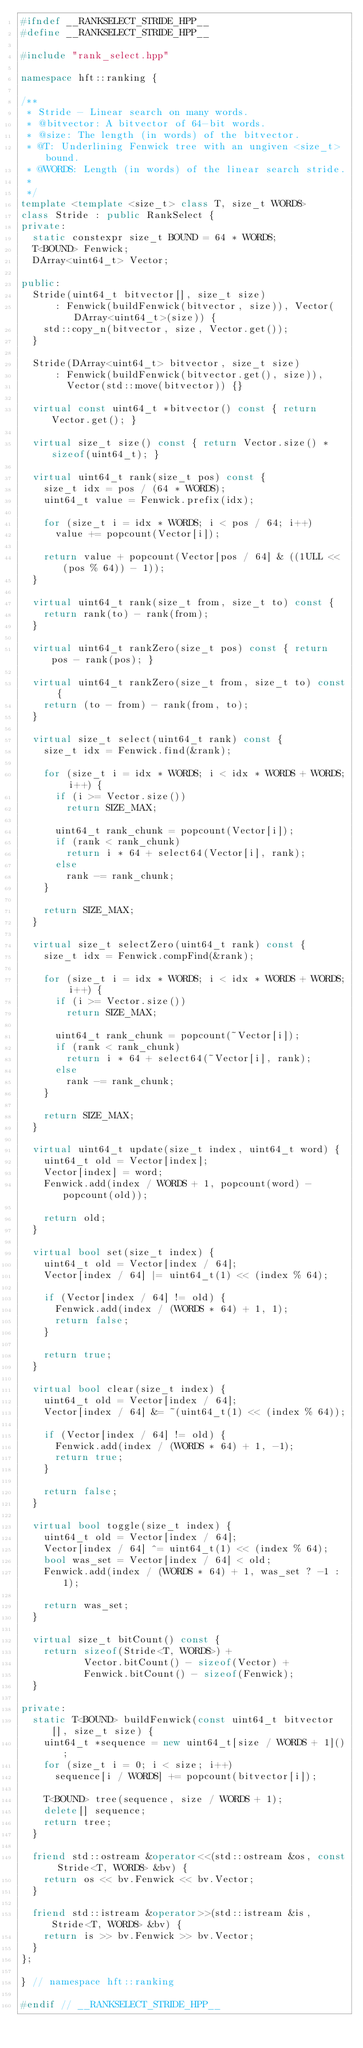Convert code to text. <code><loc_0><loc_0><loc_500><loc_500><_C++_>#ifndef __RANKSELECT_STRIDE_HPP__
#define __RANKSELECT_STRIDE_HPP__

#include "rank_select.hpp"

namespace hft::ranking {

/**
 * Stride - Linear search on many words.
 * @bitvector: A bitvector of 64-bit words.
 * @size: The length (in words) of the bitvector.
 * @T: Underlining Fenwick tree with an ungiven <size_t> bound.
 * @WORDS: Length (in words) of the linear search stride.
 *
 */
template <template <size_t> class T, size_t WORDS>
class Stride : public RankSelect {
private:
  static constexpr size_t BOUND = 64 * WORDS;
  T<BOUND> Fenwick;
  DArray<uint64_t> Vector;

public:
  Stride(uint64_t bitvector[], size_t size)
      : Fenwick(buildFenwick(bitvector, size)), Vector(DArray<uint64_t>(size)) {
    std::copy_n(bitvector, size, Vector.get());
  }

  Stride(DArray<uint64_t> bitvector, size_t size)
      : Fenwick(buildFenwick(bitvector.get(), size)),
        Vector(std::move(bitvector)) {}

  virtual const uint64_t *bitvector() const { return Vector.get(); }

  virtual size_t size() const { return Vector.size() * sizeof(uint64_t); }

  virtual uint64_t rank(size_t pos) const {
    size_t idx = pos / (64 * WORDS);
    uint64_t value = Fenwick.prefix(idx);

    for (size_t i = idx * WORDS; i < pos / 64; i++)
      value += popcount(Vector[i]);

    return value + popcount(Vector[pos / 64] & ((1ULL << (pos % 64)) - 1));
  }

  virtual uint64_t rank(size_t from, size_t to) const {
    return rank(to) - rank(from);
  }

  virtual uint64_t rankZero(size_t pos) const { return pos - rank(pos); }

  virtual uint64_t rankZero(size_t from, size_t to) const {
    return (to - from) - rank(from, to);
  }

  virtual size_t select(uint64_t rank) const {
    size_t idx = Fenwick.find(&rank);

    for (size_t i = idx * WORDS; i < idx * WORDS + WORDS; i++) {
      if (i >= Vector.size())
        return SIZE_MAX;

      uint64_t rank_chunk = popcount(Vector[i]);
      if (rank < rank_chunk)
        return i * 64 + select64(Vector[i], rank);
      else
        rank -= rank_chunk;
    }

    return SIZE_MAX;
  }

  virtual size_t selectZero(uint64_t rank) const {
    size_t idx = Fenwick.compFind(&rank);

    for (size_t i = idx * WORDS; i < idx * WORDS + WORDS; i++) {
      if (i >= Vector.size())
        return SIZE_MAX;

      uint64_t rank_chunk = popcount(~Vector[i]);
      if (rank < rank_chunk)
        return i * 64 + select64(~Vector[i], rank);
      else
        rank -= rank_chunk;
    }

    return SIZE_MAX;
  }

  virtual uint64_t update(size_t index, uint64_t word) {
    uint64_t old = Vector[index];
    Vector[index] = word;
    Fenwick.add(index / WORDS + 1, popcount(word) - popcount(old));

    return old;
  }

  virtual bool set(size_t index) {
    uint64_t old = Vector[index / 64];
    Vector[index / 64] |= uint64_t(1) << (index % 64);

    if (Vector[index / 64] != old) {
      Fenwick.add(index / (WORDS * 64) + 1, 1);
      return false;
    }

    return true;
  }

  virtual bool clear(size_t index) {
    uint64_t old = Vector[index / 64];
    Vector[index / 64] &= ~(uint64_t(1) << (index % 64));

    if (Vector[index / 64] != old) {
      Fenwick.add(index / (WORDS * 64) + 1, -1);
      return true;
    }

    return false;
  }

  virtual bool toggle(size_t index) {
    uint64_t old = Vector[index / 64];
    Vector[index / 64] ^= uint64_t(1) << (index % 64);
    bool was_set = Vector[index / 64] < old;
    Fenwick.add(index / (WORDS * 64) + 1, was_set ? -1 : 1);

    return was_set;
  }

  virtual size_t bitCount() const {
    return sizeof(Stride<T, WORDS>) +
           Vector.bitCount() - sizeof(Vector) +
           Fenwick.bitCount() - sizeof(Fenwick);
  }

private:
  static T<BOUND> buildFenwick(const uint64_t bitvector[], size_t size) {
    uint64_t *sequence = new uint64_t[size / WORDS + 1]();
    for (size_t i = 0; i < size; i++)
      sequence[i / WORDS] += popcount(bitvector[i]);

    T<BOUND> tree(sequence, size / WORDS + 1);
    delete[] sequence;
    return tree;
  }

  friend std::ostream &operator<<(std::ostream &os, const Stride<T, WORDS> &bv) {
    return os << bv.Fenwick << bv.Vector;
  }

  friend std::istream &operator>>(std::istream &is, Stride<T, WORDS> &bv) {
    return is >> bv.Fenwick >> bv.Vector;
  }
};

} // namespace hft::ranking

#endif // __RANKSELECT_STRIDE_HPP__
</code> 